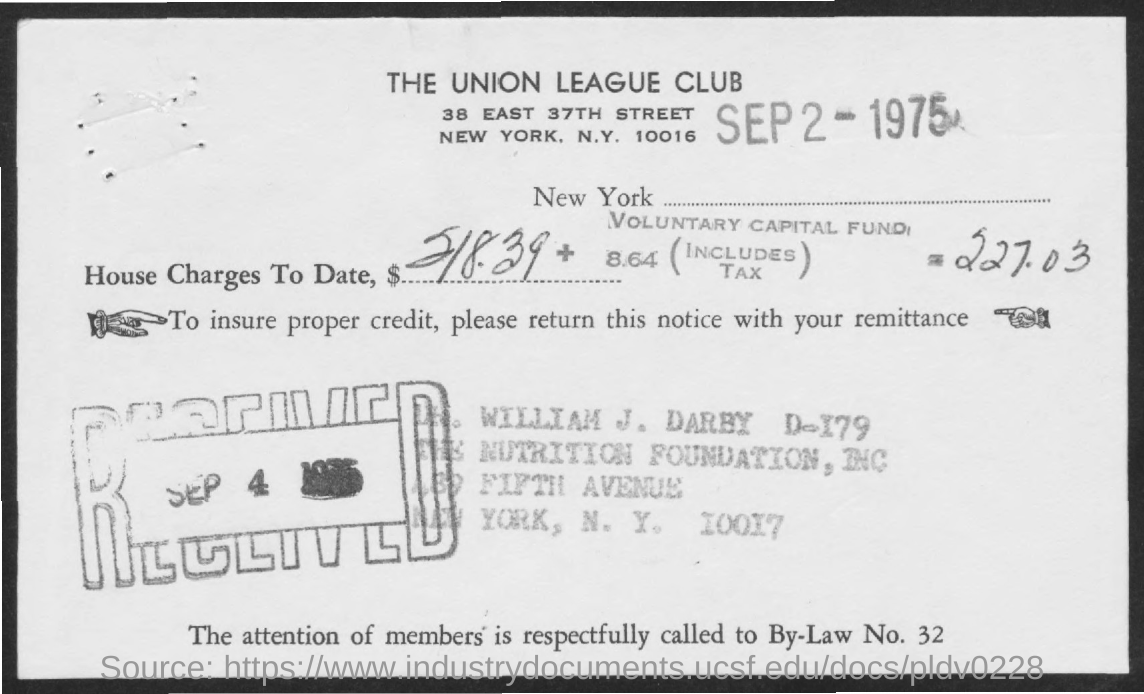Outline some significant characteristics in this image. On September 4th, 1975, the date received was. The date on the document is September 2, 1975. 